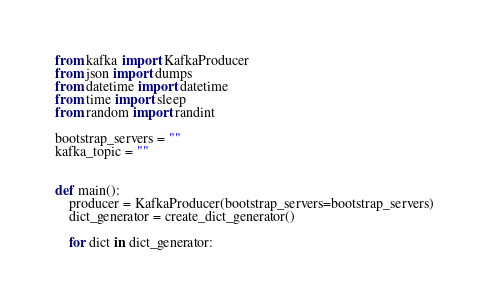Convert code to text. <code><loc_0><loc_0><loc_500><loc_500><_Python_>from kafka import KafkaProducer
from json import dumps
from datetime import datetime
from time import sleep
from random import randint

bootstrap_servers = ""
kafka_topic = ""


def main():
    producer = KafkaProducer(bootstrap_servers=bootstrap_servers)
    dict_generator = create_dict_generator()

    for dict in dict_generator:</code> 